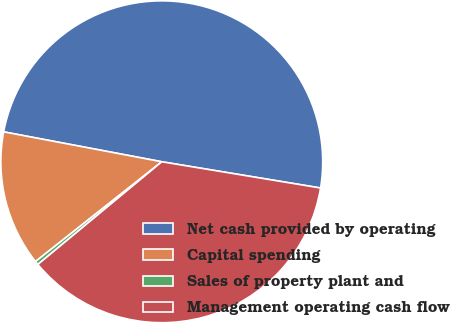Convert chart to OTSL. <chart><loc_0><loc_0><loc_500><loc_500><pie_chart><fcel>Net cash provided by operating<fcel>Capital spending<fcel>Sales of property plant and<fcel>Management operating cash flow<nl><fcel>49.63%<fcel>13.62%<fcel>0.37%<fcel>36.38%<nl></chart> 